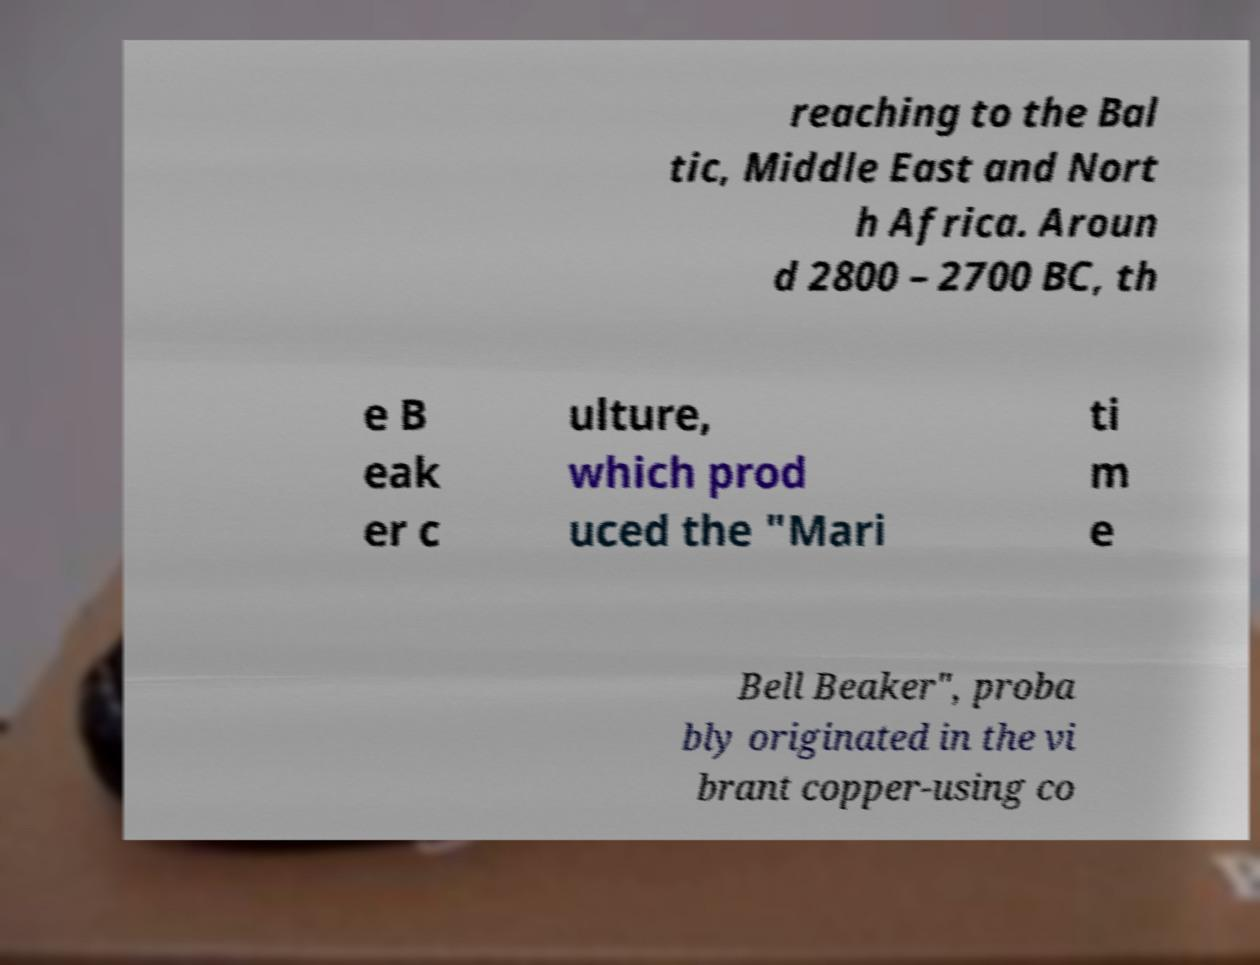Can you read and provide the text displayed in the image?This photo seems to have some interesting text. Can you extract and type it out for me? reaching to the Bal tic, Middle East and Nort h Africa. Aroun d 2800 – 2700 BC, th e B eak er c ulture, which prod uced the "Mari ti m e Bell Beaker", proba bly originated in the vi brant copper-using co 